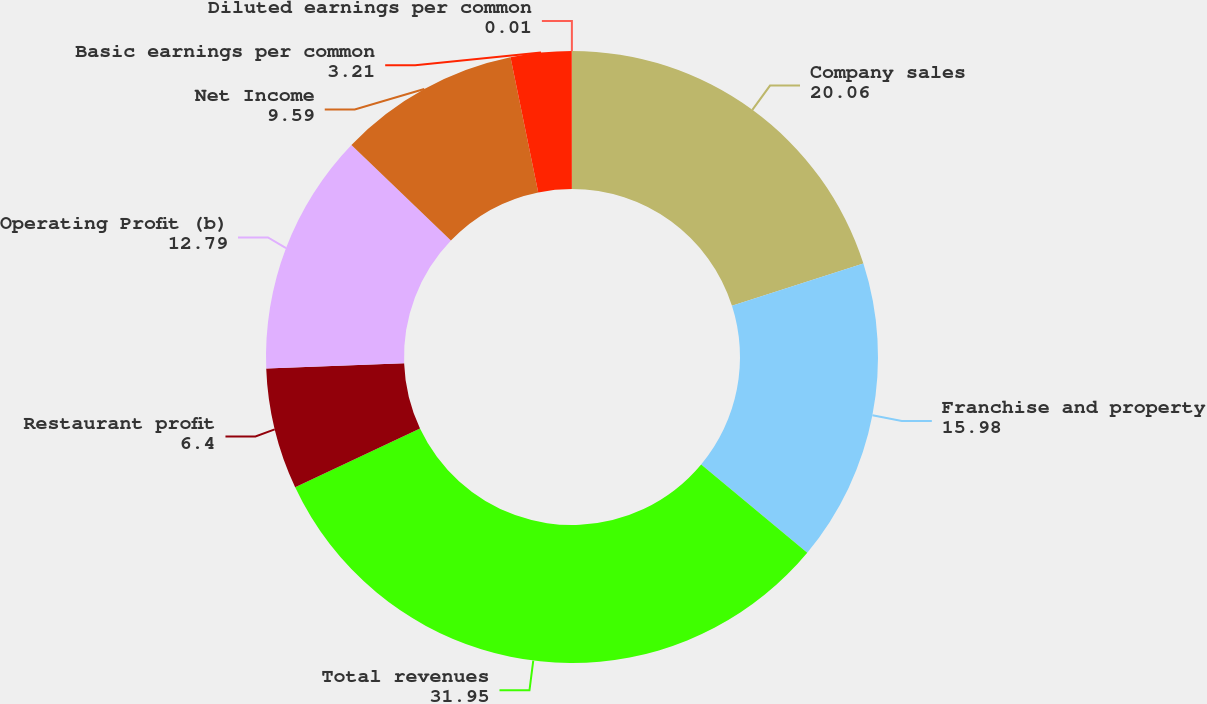Convert chart to OTSL. <chart><loc_0><loc_0><loc_500><loc_500><pie_chart><fcel>Company sales<fcel>Franchise and property<fcel>Total revenues<fcel>Restaurant profit<fcel>Operating Profit (b)<fcel>Net Income<fcel>Basic earnings per common<fcel>Diluted earnings per common<nl><fcel>20.06%<fcel>15.98%<fcel>31.95%<fcel>6.4%<fcel>12.79%<fcel>9.59%<fcel>3.21%<fcel>0.01%<nl></chart> 